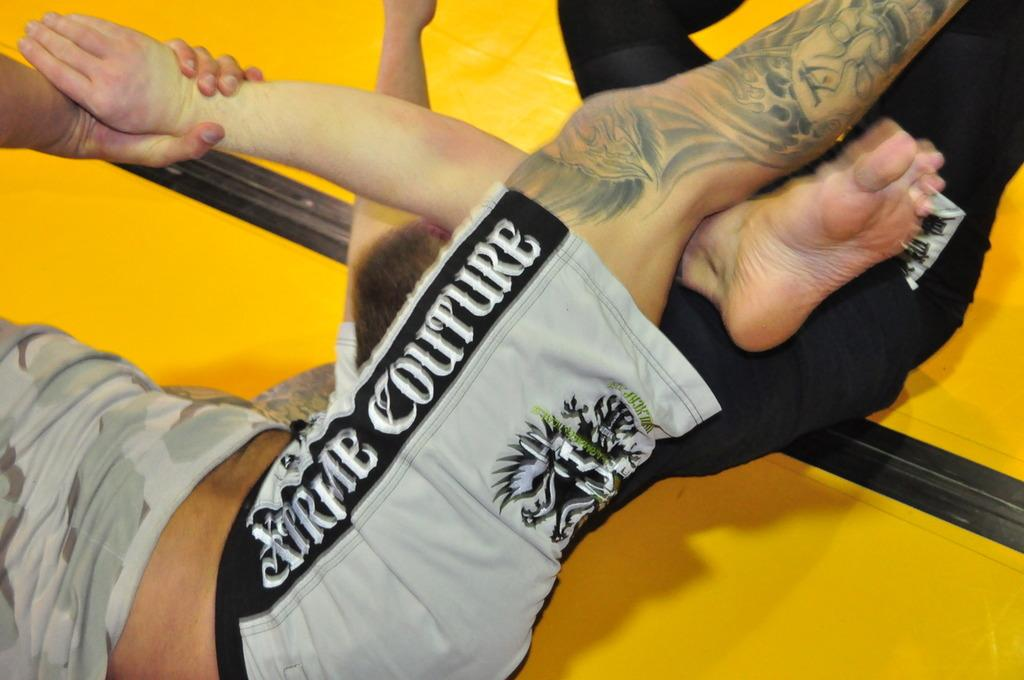<image>
Give a short and clear explanation of the subsequent image. tattoo legs of a guy wearing gray and black xtreme couture shorts 